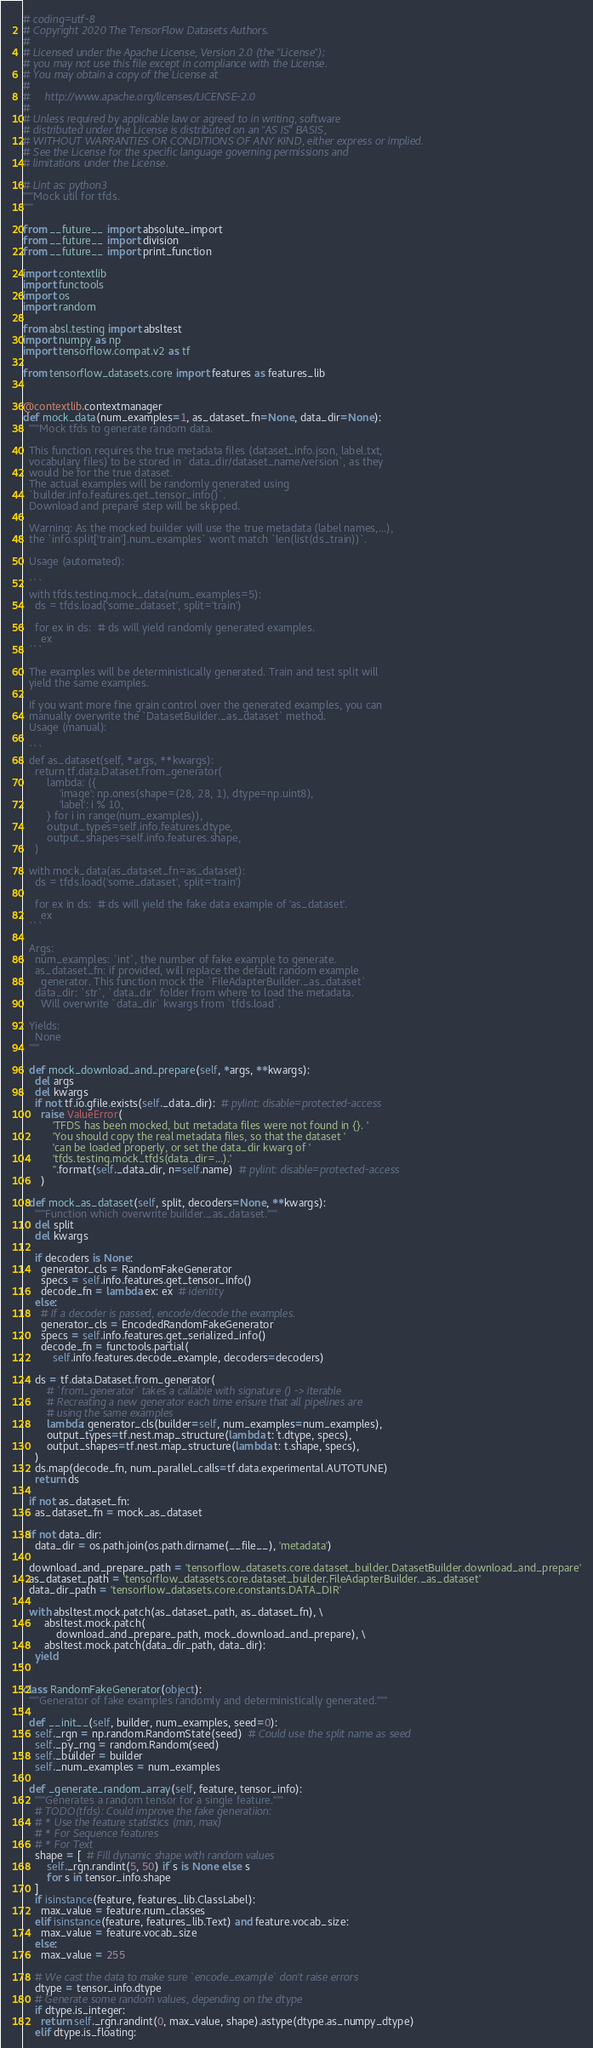Convert code to text. <code><loc_0><loc_0><loc_500><loc_500><_Python_># coding=utf-8
# Copyright 2020 The TensorFlow Datasets Authors.
#
# Licensed under the Apache License, Version 2.0 (the "License");
# you may not use this file except in compliance with the License.
# You may obtain a copy of the License at
#
#     http://www.apache.org/licenses/LICENSE-2.0
#
# Unless required by applicable law or agreed to in writing, software
# distributed under the License is distributed on an "AS IS" BASIS,
# WITHOUT WARRANTIES OR CONDITIONS OF ANY KIND, either express or implied.
# See the License for the specific language governing permissions and
# limitations under the License.

# Lint as: python3
"""Mock util for tfds.
"""

from __future__ import absolute_import
from __future__ import division
from __future__ import print_function

import contextlib
import functools
import os
import random

from absl.testing import absltest
import numpy as np
import tensorflow.compat.v2 as tf

from tensorflow_datasets.core import features as features_lib


@contextlib.contextmanager
def mock_data(num_examples=1, as_dataset_fn=None, data_dir=None):
  """Mock tfds to generate random data.

  This function requires the true metadata files (dataset_info.json, label.txt,
  vocabulary files) to be stored in `data_dir/dataset_name/version`, as they
  would be for the true dataset.
  The actual examples will be randomly generated using
  `builder.info.features.get_tensor_info()`.
  Download and prepare step will be skipped.

  Warning: As the mocked builder will use the true metadata (label names,...),
  the `info.split['train'].num_examples` won't match `len(list(ds_train))`.

  Usage (automated):

  ```
  with tfds.testing.mock_data(num_examples=5):
    ds = tfds.load('some_dataset', split='train')

    for ex in ds:  # ds will yield randomly generated examples.
      ex
  ```

  The examples will be deterministically generated. Train and test split will
  yield the same examples.

  If you want more fine grain control over the generated examples, you can
  manually overwrite the `DatasetBuilder._as_dataset` method.
  Usage (manual):

  ```
  def as_dataset(self, *args, **kwargs):
    return tf.data.Dataset.from_generator(
        lambda: ({
            'image': np.ones(shape=(28, 28, 1), dtype=np.uint8),
            'label': i % 10,
        } for i in range(num_examples)),
        output_types=self.info.features.dtype,
        output_shapes=self.info.features.shape,
    )

  with mock_data(as_dataset_fn=as_dataset):
    ds = tfds.load('some_dataset', split='train')

    for ex in ds:  # ds will yield the fake data example of 'as_dataset'.
      ex
  ```

  Args:
    num_examples: `int`, the number of fake example to generate.
    as_dataset_fn: if provided, will replace the default random example
      generator. This function mock the `FileAdapterBuilder._as_dataset`
    data_dir: `str`, `data_dir` folder from where to load the metadata.
      Will overwrite `data_dir` kwargs from `tfds.load`.

  Yields:
    None
  """

  def mock_download_and_prepare(self, *args, **kwargs):
    del args
    del kwargs
    if not tf.io.gfile.exists(self._data_dir):  # pylint: disable=protected-access
      raise ValueError(
          'TFDS has been mocked, but metadata files were not found in {}. '
          'You should copy the real metadata files, so that the dataset '
          'can be loaded properly, or set the data_dir kwarg of '
          'tfds.testing.mock_tfds(data_dir=...).'
          ''.format(self._data_dir, n=self.name)  # pylint: disable=protected-access
      )

  def mock_as_dataset(self, split, decoders=None, **kwargs):
    """Function which overwrite builder._as_dataset."""
    del split
    del kwargs

    if decoders is None:
      generator_cls = RandomFakeGenerator
      specs = self.info.features.get_tensor_info()
      decode_fn = lambda ex: ex  # identity
    else:
      # If a decoder is passed, encode/decode the examples.
      generator_cls = EncodedRandomFakeGenerator
      specs = self.info.features.get_serialized_info()
      decode_fn = functools.partial(
          self.info.features.decode_example, decoders=decoders)

    ds = tf.data.Dataset.from_generator(
        # `from_generator` takes a callable with signature () -> iterable
        # Recreating a new generator each time ensure that all pipelines are
        # using the same examples
        lambda: generator_cls(builder=self, num_examples=num_examples),
        output_types=tf.nest.map_structure(lambda t: t.dtype, specs),
        output_shapes=tf.nest.map_structure(lambda t: t.shape, specs),
    )
    ds.map(decode_fn, num_parallel_calls=tf.data.experimental.AUTOTUNE)
    return ds

  if not as_dataset_fn:
    as_dataset_fn = mock_as_dataset

  if not data_dir:
    data_dir = os.path.join(os.path.dirname(__file__), 'metadata')

  download_and_prepare_path = 'tensorflow_datasets.core.dataset_builder.DatasetBuilder.download_and_prepare'
  as_dataset_path = 'tensorflow_datasets.core.dataset_builder.FileAdapterBuilder._as_dataset'
  data_dir_path = 'tensorflow_datasets.core.constants.DATA_DIR'

  with absltest.mock.patch(as_dataset_path, as_dataset_fn), \
       absltest.mock.patch(
           download_and_prepare_path, mock_download_and_prepare), \
       absltest.mock.patch(data_dir_path, data_dir):
    yield


class RandomFakeGenerator(object):
  """Generator of fake examples randomly and deterministically generated."""

  def __init__(self, builder, num_examples, seed=0):
    self._rgn = np.random.RandomState(seed)  # Could use the split name as seed
    self._py_rng = random.Random(seed)
    self._builder = builder
    self._num_examples = num_examples

  def _generate_random_array(self, feature, tensor_info):
    """Generates a random tensor for a single feature."""
    # TODO(tfds): Could improve the fake generatiion:
    # * Use the feature statistics (min, max)
    # * For Sequence features
    # * For Text
    shape = [  # Fill dynamic shape with random values
        self._rgn.randint(5, 50) if s is None else s
        for s in tensor_info.shape
    ]
    if isinstance(feature, features_lib.ClassLabel):
      max_value = feature.num_classes
    elif isinstance(feature, features_lib.Text) and feature.vocab_size:
      max_value = feature.vocab_size
    else:
      max_value = 255

    # We cast the data to make sure `encode_example` don't raise errors
    dtype = tensor_info.dtype
    # Generate some random values, depending on the dtype
    if dtype.is_integer:
      return self._rgn.randint(0, max_value, shape).astype(dtype.as_numpy_dtype)
    elif dtype.is_floating:</code> 